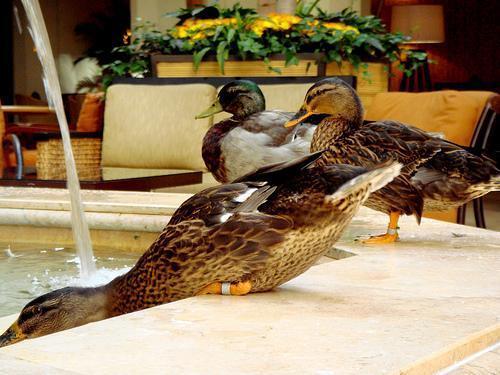How many ducks are actively touching the water in this image?
Give a very brief answer. 1. How many ducks are standing up?
Give a very brief answer. 2. 